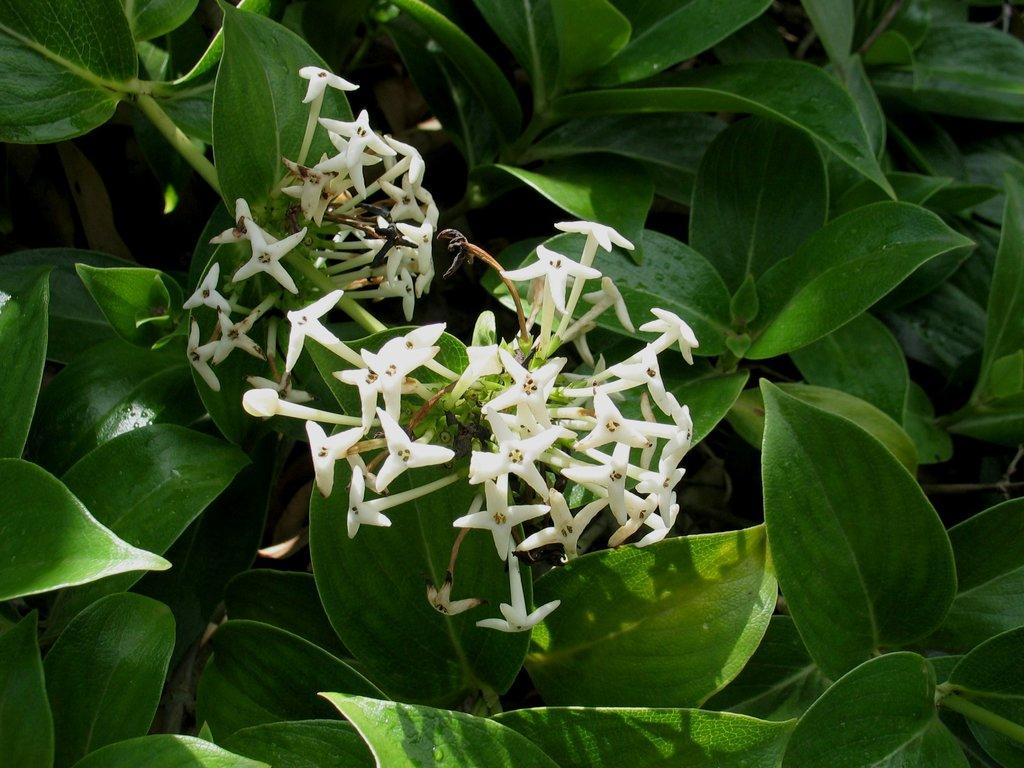What type of living organism can be seen in the image? There is a plant in the image. What color are the flowers on the plant? The flowers on the plant are white. What type of stamp is on the plant in the image? There is no stamp present on the plant in the image. What kind of bag is hanging from the plant in the image? There is no bag hanging from the plant in the image. 